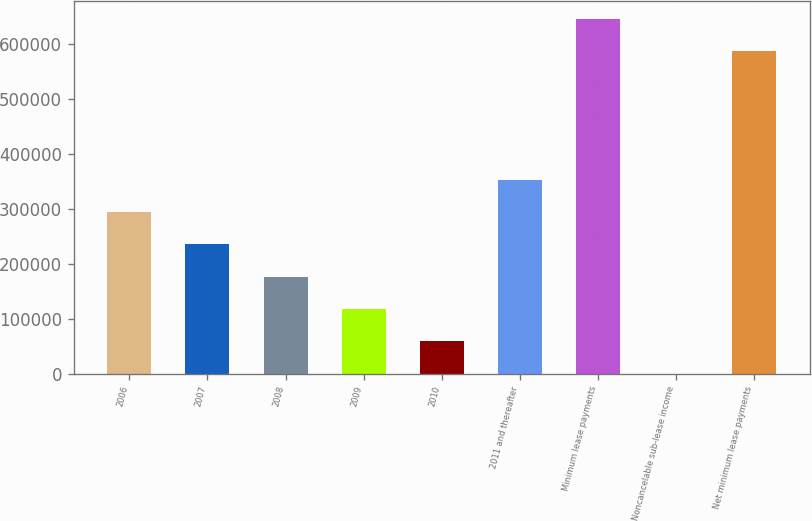Convert chart to OTSL. <chart><loc_0><loc_0><loc_500><loc_500><bar_chart><fcel>2006<fcel>2007<fcel>2008<fcel>2009<fcel>2010<fcel>2011 and thereafter<fcel>Minimum lease payments<fcel>Noncancelable sub-lease income<fcel>Net minimum lease payments<nl><fcel>293560<fcel>234867<fcel>176174<fcel>117480<fcel>58787.2<fcel>352253<fcel>645625<fcel>94<fcel>586932<nl></chart> 